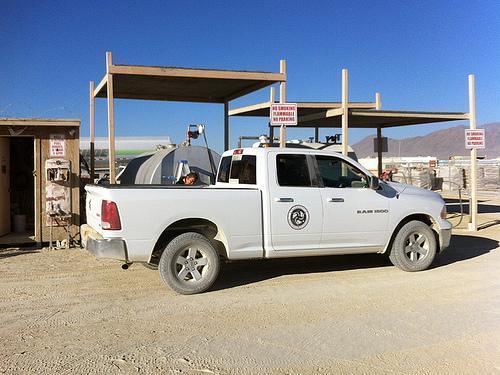How many tires are visible?
Give a very brief answer. 2. 